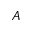<formula> <loc_0><loc_0><loc_500><loc_500>A</formula> 